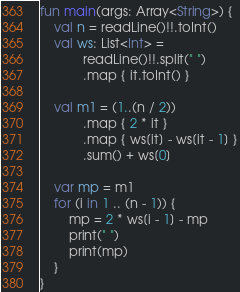Convert code to text. <code><loc_0><loc_0><loc_500><loc_500><_Kotlin_>fun main(args: Array<String>) {
    val n = readLine()!!.toInt()
    val ws: List<Int> =
            readLine()!!.split(" ")
            .map { it.toInt() }

    val m1 = (1..(n / 2))
            .map { 2 * it }
            .map { ws[it] - ws[it - 1] }
            .sum() + ws[0]

    var mp = m1
    for (i in 1 .. (n - 1)) {
        mp = 2 * ws[i - 1] - mp
        print(" ")
        print(mp)
    }
}
</code> 